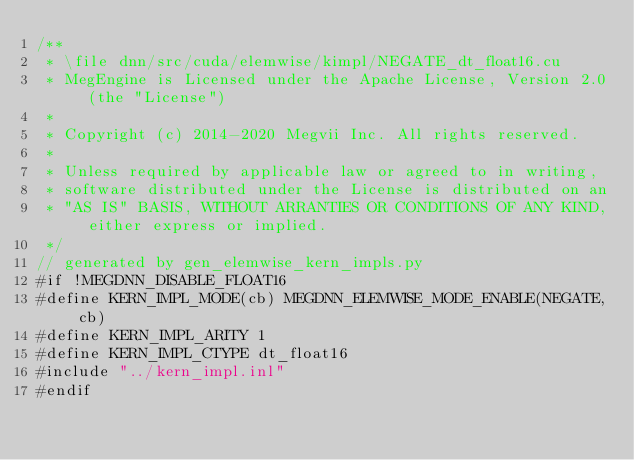Convert code to text. <code><loc_0><loc_0><loc_500><loc_500><_Cuda_>/**
 * \file dnn/src/cuda/elemwise/kimpl/NEGATE_dt_float16.cu
 * MegEngine is Licensed under the Apache License, Version 2.0 (the "License")
 *
 * Copyright (c) 2014-2020 Megvii Inc. All rights reserved.
 *
 * Unless required by applicable law or agreed to in writing,
 * software distributed under the License is distributed on an
 * "AS IS" BASIS, WITHOUT ARRANTIES OR CONDITIONS OF ANY KIND, either express or implied.
 */
// generated by gen_elemwise_kern_impls.py
#if !MEGDNN_DISABLE_FLOAT16
#define KERN_IMPL_MODE(cb) MEGDNN_ELEMWISE_MODE_ENABLE(NEGATE, cb)
#define KERN_IMPL_ARITY 1
#define KERN_IMPL_CTYPE dt_float16
#include "../kern_impl.inl"
#endif
</code> 